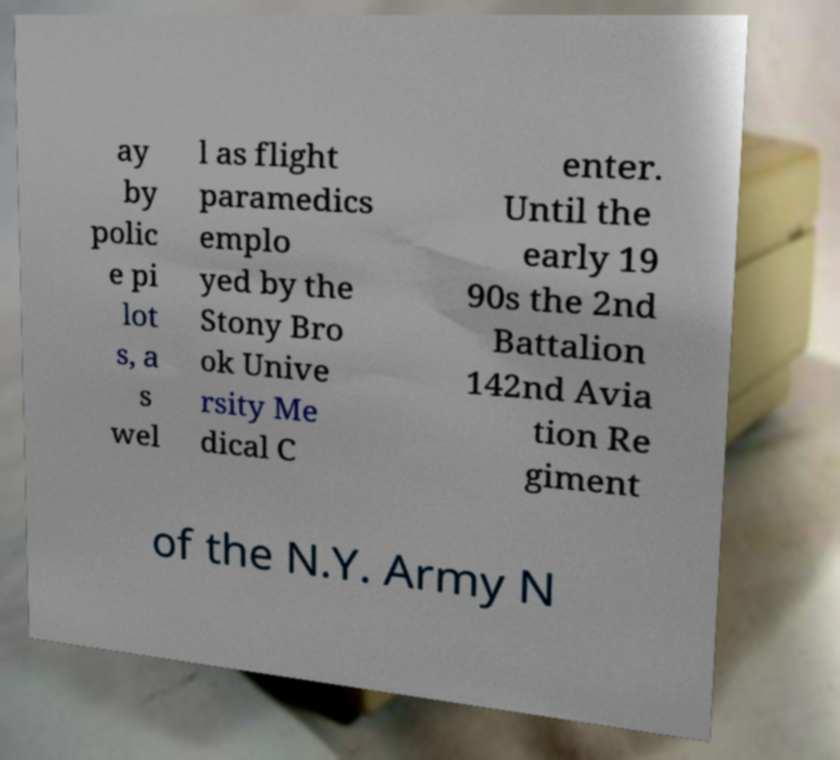For documentation purposes, I need the text within this image transcribed. Could you provide that? ay by polic e pi lot s, a s wel l as flight paramedics emplo yed by the Stony Bro ok Unive rsity Me dical C enter. Until the early 19 90s the 2nd Battalion 142nd Avia tion Re giment of the N.Y. Army N 